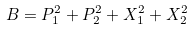<formula> <loc_0><loc_0><loc_500><loc_500>B = P _ { 1 } ^ { 2 } + P _ { 2 } ^ { 2 } + X _ { 1 } ^ { 2 } + X _ { 2 } ^ { 2 }</formula> 